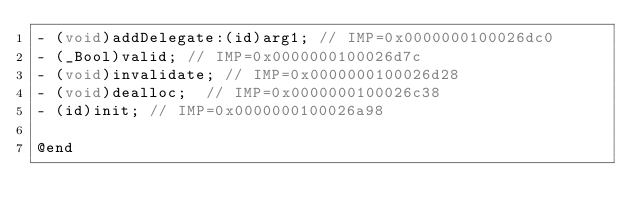Convert code to text. <code><loc_0><loc_0><loc_500><loc_500><_C_>- (void)addDelegate:(id)arg1;	// IMP=0x0000000100026dc0
- (_Bool)valid;	// IMP=0x0000000100026d7c
- (void)invalidate;	// IMP=0x0000000100026d28
- (void)dealloc;	// IMP=0x0000000100026c38
- (id)init;	// IMP=0x0000000100026a98

@end

</code> 